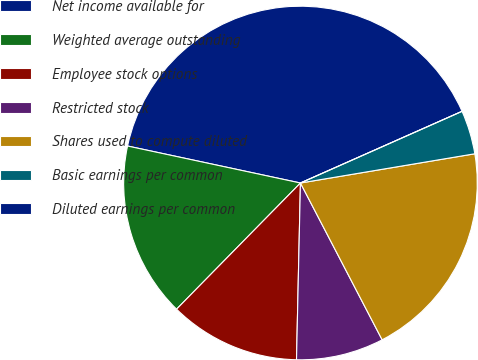Convert chart. <chart><loc_0><loc_0><loc_500><loc_500><pie_chart><fcel>Net income available for<fcel>Weighted average outstanding<fcel>Employee stock options<fcel>Restricted stock<fcel>Shares used to compute diluted<fcel>Basic earnings per common<fcel>Diluted earnings per common<nl><fcel>40.0%<fcel>16.0%<fcel>12.0%<fcel>8.0%<fcel>20.0%<fcel>4.0%<fcel>0.0%<nl></chart> 